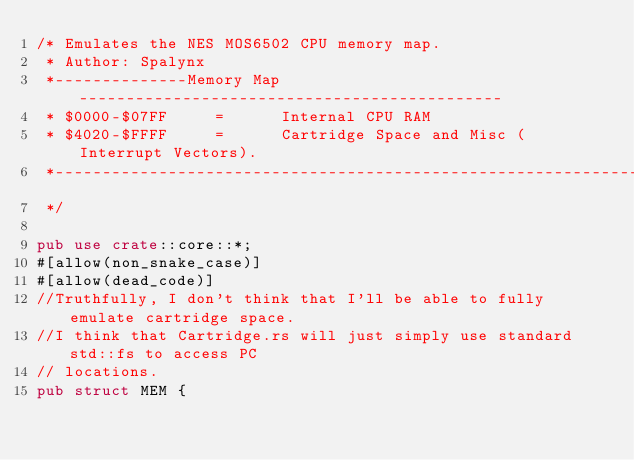<code> <loc_0><loc_0><loc_500><loc_500><_Rust_>/* Emulates the NES MOS6502 CPU memory map.
 * Author: Spalynx
 *--------------Memory Map---------------------------------------------
 * $0000-$07FF     =      Internal CPU RAM
 * $4020-$FFFF     =      Cartridge Space and Misc (Interrupt Vectors).
 *---------------------------------------------------------------------
 */

pub use crate::core::*;
#[allow(non_snake_case)]
#[allow(dead_code)]
//Truthfully, I don't think that I'll be able to fully emulate cartridge space.
//I think that Cartridge.rs will just simply use standard std::fs to access PC
// locations.
pub struct MEM {</code> 